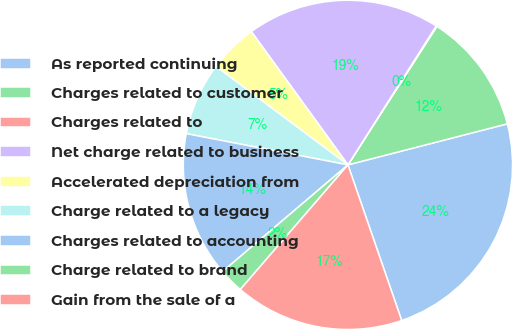Convert chart to OTSL. <chart><loc_0><loc_0><loc_500><loc_500><pie_chart><fcel>As reported continuing<fcel>Charges related to customer<fcel>Charges related to<fcel>Net charge related to business<fcel>Accelerated depreciation from<fcel>Charge related to a legacy<fcel>Charges related to accounting<fcel>Charge related to brand<fcel>Gain from the sale of a<nl><fcel>23.72%<fcel>11.9%<fcel>0.08%<fcel>18.99%<fcel>4.81%<fcel>7.17%<fcel>14.26%<fcel>2.44%<fcel>16.63%<nl></chart> 